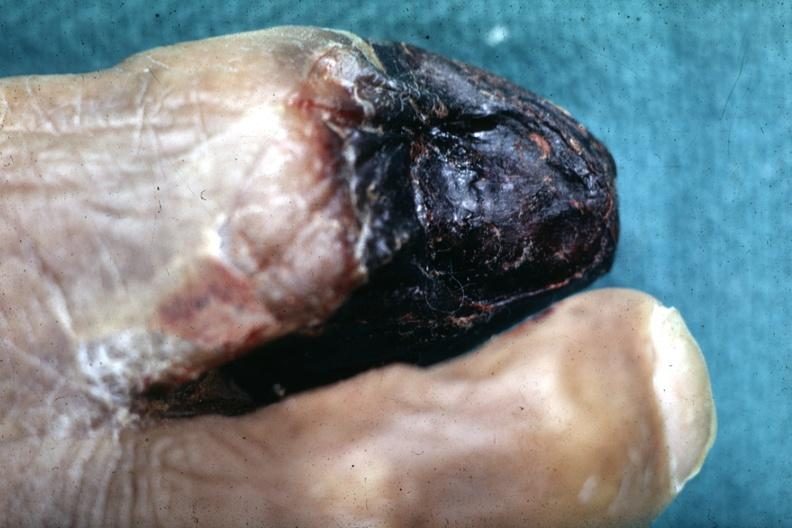re extremities present?
Answer the question using a single word or phrase. Yes 